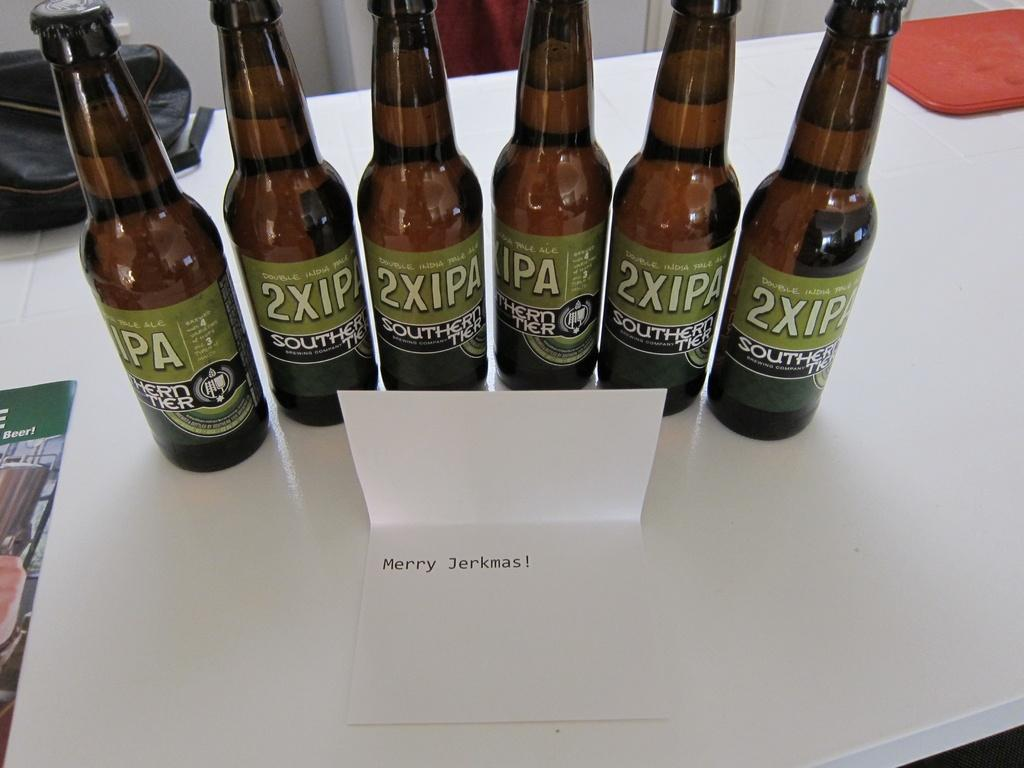How many bottles are on the table in the image? There are six bottles on the table in the image. What is written on the paper note in front of the bottles? The paper note is named "merry sharkmas." Can you describe any other objects on the table? There is a bag present on the table. What type of brain is visible in the image? There is no brain present in the image. Can you describe the gate in the image? There is no gate present in the image. 